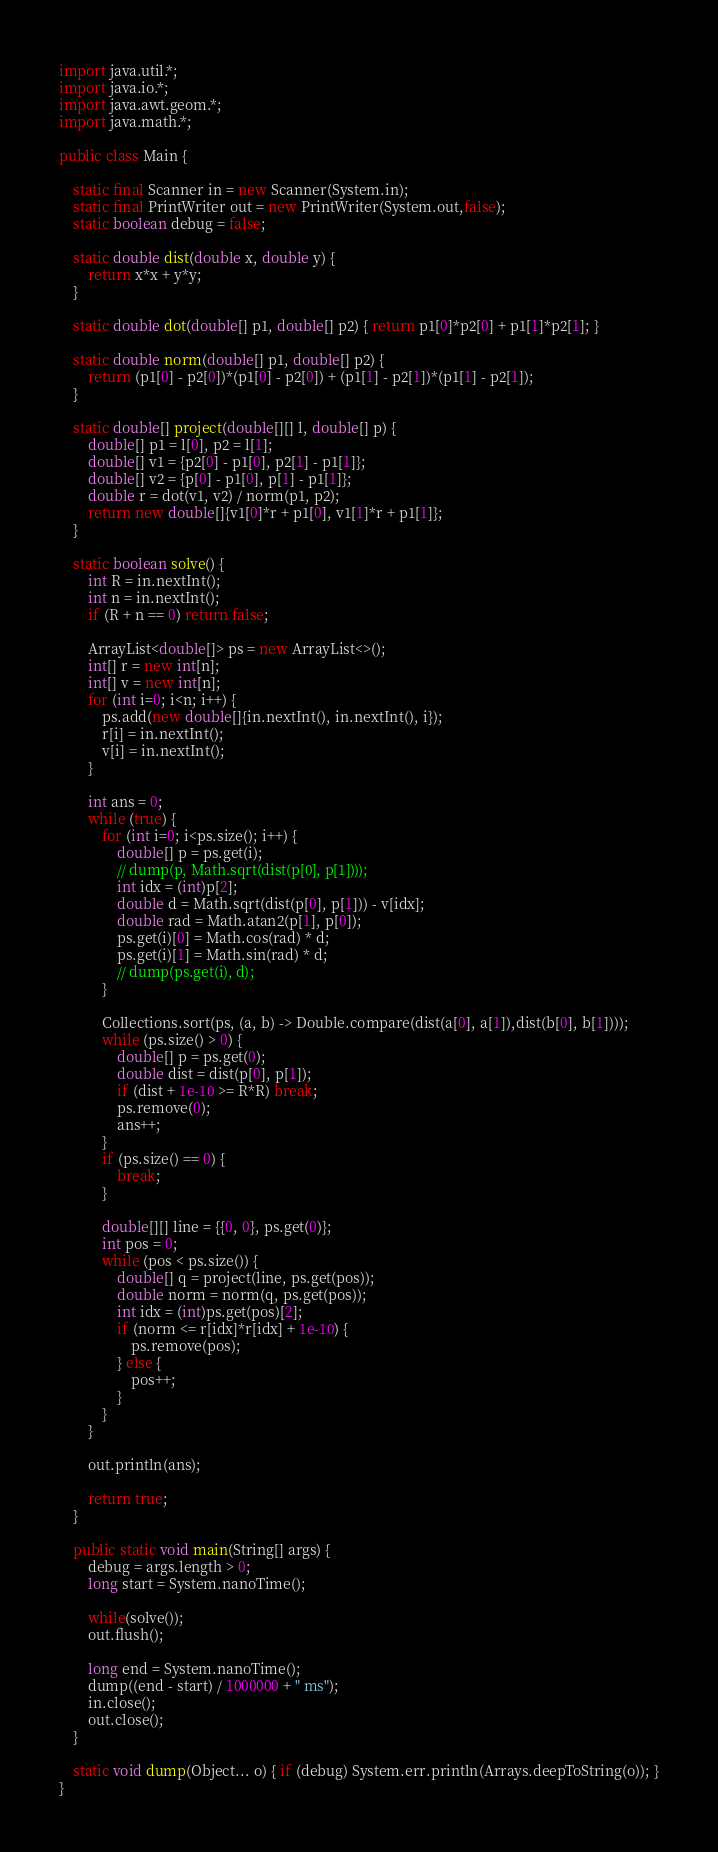Convert code to text. <code><loc_0><loc_0><loc_500><loc_500><_Java_>import java.util.*;
import java.io.*;
import java.awt.geom.*;
import java.math.*;

public class Main {

	static final Scanner in = new Scanner(System.in);
	static final PrintWriter out = new PrintWriter(System.out,false);
	static boolean debug = false;

	static double dist(double x, double y) {
		return x*x + y*y;
	}

	static double dot(double[] p1, double[] p2) { return p1[0]*p2[0] + p1[1]*p2[1]; }

	static double norm(double[] p1, double[] p2) {
		return (p1[0] - p2[0])*(p1[0] - p2[0]) + (p1[1] - p2[1])*(p1[1] - p2[1]);
	}

	static double[] project(double[][] l, double[] p) {
		double[] p1 = l[0], p2 = l[1];
		double[] v1 = {p2[0] - p1[0], p2[1] - p1[1]};
		double[] v2 = {p[0] - p1[0], p[1] - p1[1]};
		double r = dot(v1, v2) / norm(p1, p2);
		return new double[]{v1[0]*r + p1[0], v1[1]*r + p1[1]};
	}

	static boolean solve() {
		int R = in.nextInt();
		int n = in.nextInt();
		if (R + n == 0) return false;

		ArrayList<double[]> ps = new ArrayList<>();
		int[] r = new int[n];
		int[] v = new int[n];
		for (int i=0; i<n; i++) {
			ps.add(new double[]{in.nextInt(), in.nextInt(), i});
			r[i] = in.nextInt();
			v[i] = in.nextInt();
		}

		int ans = 0;
		while (true) {
			for (int i=0; i<ps.size(); i++) {
				double[] p = ps.get(i);
				// dump(p, Math.sqrt(dist(p[0], p[1])));
				int idx = (int)p[2];
				double d = Math.sqrt(dist(p[0], p[1])) - v[idx];
				double rad = Math.atan2(p[1], p[0]);
				ps.get(i)[0] = Math.cos(rad) * d;
				ps.get(i)[1] = Math.sin(rad) * d;
				// dump(ps.get(i), d);
			}

			Collections.sort(ps, (a, b) -> Double.compare(dist(a[0], a[1]),dist(b[0], b[1])));
			while (ps.size() > 0) {
				double[] p = ps.get(0);
				double dist = dist(p[0], p[1]);
				if (dist + 1e-10 >= R*R) break;
				ps.remove(0);
				ans++;
			}
			if (ps.size() == 0) {
				break;
			}

			double[][] line = {{0, 0}, ps.get(0)};
			int pos = 0;
			while (pos < ps.size()) {
				double[] q = project(line, ps.get(pos));
				double norm = norm(q, ps.get(pos));
				int idx = (int)ps.get(pos)[2];
				if (norm <= r[idx]*r[idx] + 1e-10) {
					ps.remove(pos);
				} else {
					pos++;
				}
			}
		}

		out.println(ans);

		return true;
	}

	public static void main(String[] args) {
		debug = args.length > 0;
		long start = System.nanoTime();

		while(solve());
		out.flush();

		long end = System.nanoTime();
		dump((end - start) / 1000000 + " ms");
		in.close();
		out.close();
	}

	static void dump(Object... o) { if (debug) System.err.println(Arrays.deepToString(o)); }
}</code> 